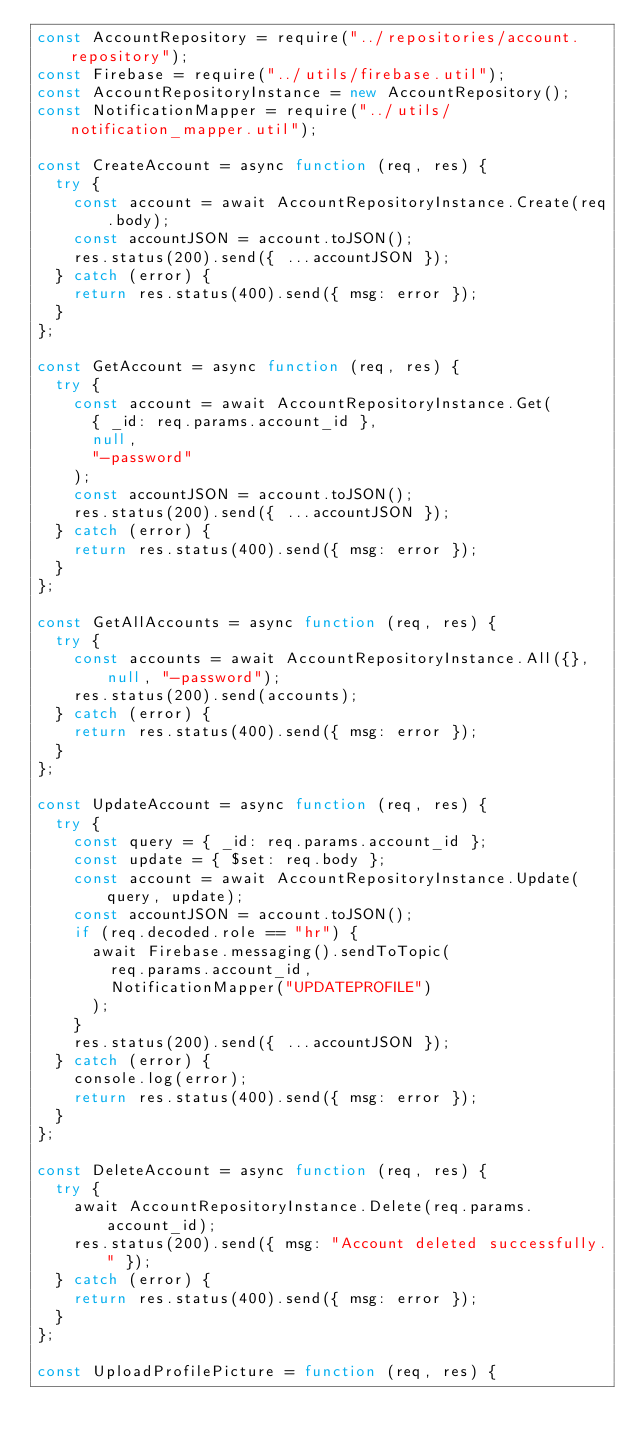Convert code to text. <code><loc_0><loc_0><loc_500><loc_500><_JavaScript_>const AccountRepository = require("../repositories/account.repository");
const Firebase = require("../utils/firebase.util");
const AccountRepositoryInstance = new AccountRepository();
const NotificationMapper = require("../utils/notification_mapper.util");

const CreateAccount = async function (req, res) {
  try {
    const account = await AccountRepositoryInstance.Create(req.body);
    const accountJSON = account.toJSON();
    res.status(200).send({ ...accountJSON });
  } catch (error) {
    return res.status(400).send({ msg: error });
  }
};

const GetAccount = async function (req, res) {
  try {
    const account = await AccountRepositoryInstance.Get(
      { _id: req.params.account_id },
      null,
      "-password"
    );
    const accountJSON = account.toJSON();
    res.status(200).send({ ...accountJSON });
  } catch (error) {
    return res.status(400).send({ msg: error });
  }
};

const GetAllAccounts = async function (req, res) {
  try {
    const accounts = await AccountRepositoryInstance.All({}, null, "-password");
    res.status(200).send(accounts);
  } catch (error) {
    return res.status(400).send({ msg: error });
  }
};

const UpdateAccount = async function (req, res) {
  try {
    const query = { _id: req.params.account_id };
    const update = { $set: req.body };
    const account = await AccountRepositoryInstance.Update(query, update);
    const accountJSON = account.toJSON();
    if (req.decoded.role == "hr") {
      await Firebase.messaging().sendToTopic(
        req.params.account_id,
        NotificationMapper("UPDATEPROFILE")
      );
    }
    res.status(200).send({ ...accountJSON });
  } catch (error) {
    console.log(error);
    return res.status(400).send({ msg: error });
  }
};

const DeleteAccount = async function (req, res) {
  try {
    await AccountRepositoryInstance.Delete(req.params.account_id);
    res.status(200).send({ msg: "Account deleted successfully." });
  } catch (error) {
    return res.status(400).send({ msg: error });
  }
};

const UploadProfilePicture = function (req, res) {</code> 